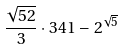Convert formula to latex. <formula><loc_0><loc_0><loc_500><loc_500>\frac { \sqrt { 5 2 } } { 3 } \cdot 3 4 1 - 2 ^ { \sqrt { 5 } }</formula> 